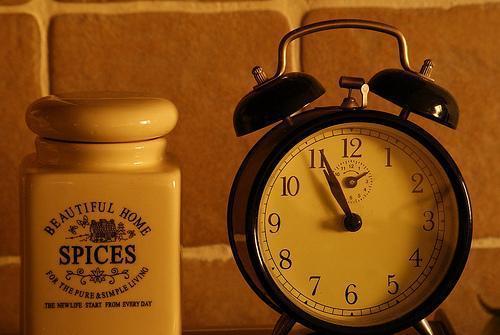How many clocks are there?
Give a very brief answer. 1. 